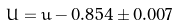Convert formula to latex. <formula><loc_0><loc_0><loc_500><loc_500>U = u - 0 . 8 5 4 \pm 0 . 0 0 7</formula> 